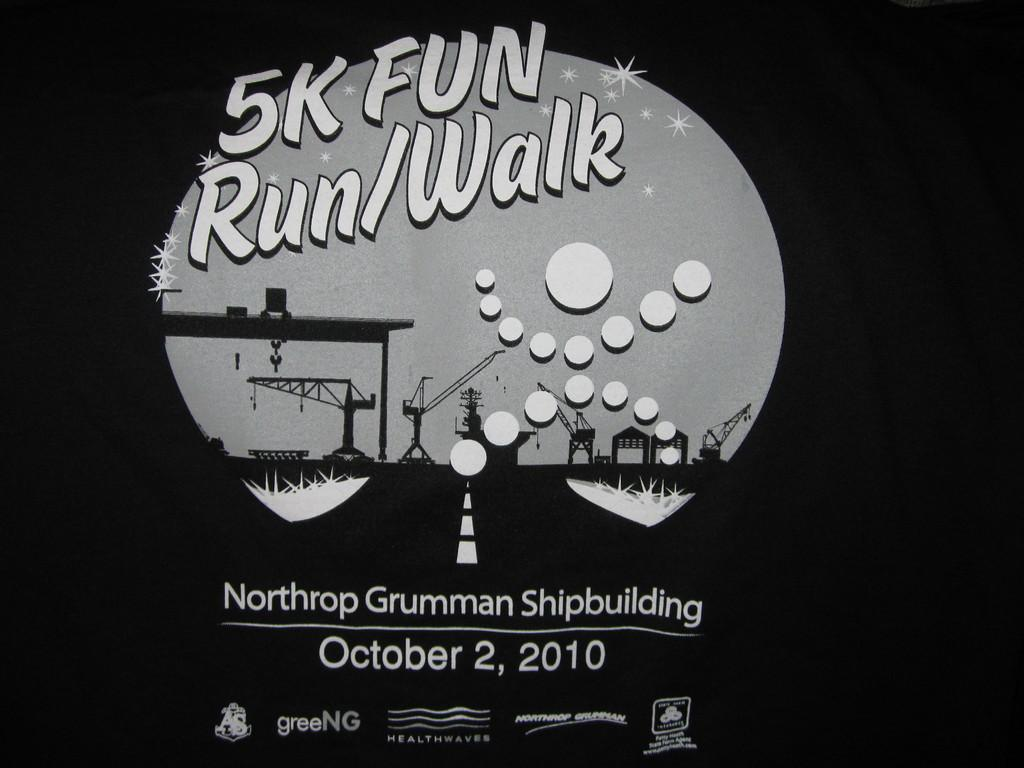What is featured on the poster in the image? There is a poster in the image, and it has text on it. What can be observed about the background of the image? The background of the image is black. What type of riddle is depicted on the poster in the image? There is no riddle depicted on the poster in the image; it only has text on it. What type of plantation is visible in the image? There is no plantation present in the image; it only features a poster with text on it and a black background. 